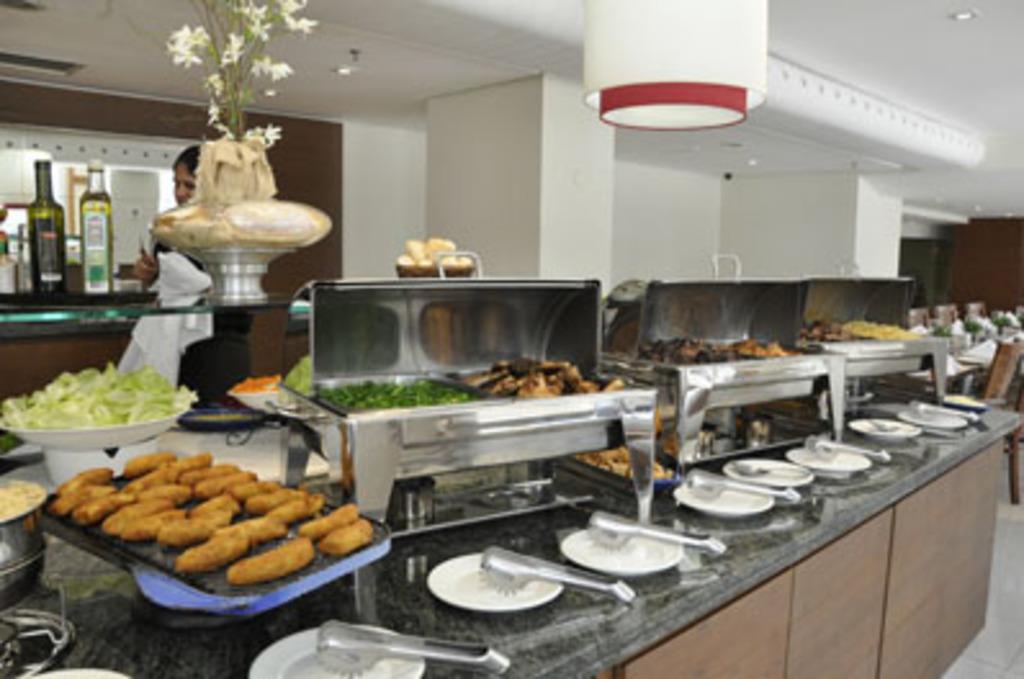Describe this image in one or two sentences. In this image there is a slab, on that slab there are plates in that plates there are tongs and there are chafing dishes, plates, bowls, in that there are food items, at the top of the slab there are flower vase and bottles, in the background there is a person standing and there is a wall, pillars, at the top there is a ceiling and lights. 